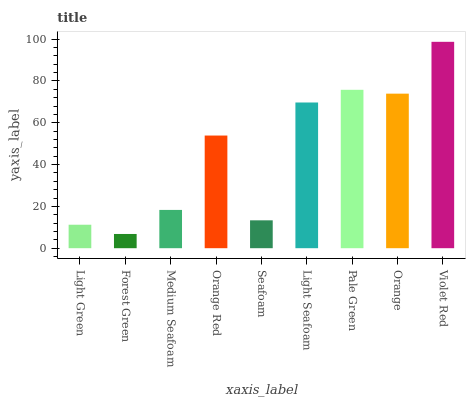Is Forest Green the minimum?
Answer yes or no. Yes. Is Violet Red the maximum?
Answer yes or no. Yes. Is Medium Seafoam the minimum?
Answer yes or no. No. Is Medium Seafoam the maximum?
Answer yes or no. No. Is Medium Seafoam greater than Forest Green?
Answer yes or no. Yes. Is Forest Green less than Medium Seafoam?
Answer yes or no. Yes. Is Forest Green greater than Medium Seafoam?
Answer yes or no. No. Is Medium Seafoam less than Forest Green?
Answer yes or no. No. Is Orange Red the high median?
Answer yes or no. Yes. Is Orange Red the low median?
Answer yes or no. Yes. Is Forest Green the high median?
Answer yes or no. No. Is Orange the low median?
Answer yes or no. No. 